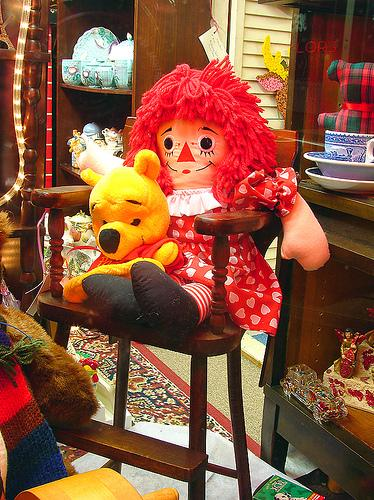What iconic child favorite is there besides Winnie the Pooh? Please explain your reasoning. raggedy ann. The doll has red hair 